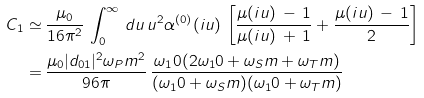<formula> <loc_0><loc_0><loc_500><loc_500>C _ { 1 } \simeq & \, \frac { \mu _ { 0 } } { 1 6 \pi ^ { 2 } } \, \int _ { 0 } ^ { \infty } \, d u \, u ^ { 2 } \alpha ^ { ( 0 ) } ( i u ) \, \left [ \frac { \mu ( i u ) \, - \, 1 } { \mu ( i u ) \, + \, 1 } + \frac { \mu ( i u ) \, - \, 1 } { 2 } \right ] \\ = & \, \frac { \mu _ { 0 } | d _ { 0 1 } | ^ { 2 } \omega _ { P } m ^ { 2 } } { 9 6 \pi } \, \frac { \omega _ { 1 } 0 ( 2 \omega _ { 1 } 0 + \omega _ { S } m + \omega _ { T } m ) } { ( \omega _ { 1 } 0 + \omega _ { S } m ) ( \omega _ { 1 } 0 + \omega _ { T } m ) }</formula> 